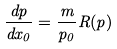<formula> <loc_0><loc_0><loc_500><loc_500>\frac { d { p } } { d x _ { 0 } } = \frac { m } { p _ { 0 } } { R } ( { p } )</formula> 